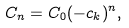<formula> <loc_0><loc_0><loc_500><loc_500>C _ { n } = C _ { 0 } ( - c _ { k } ) ^ { n } ,</formula> 